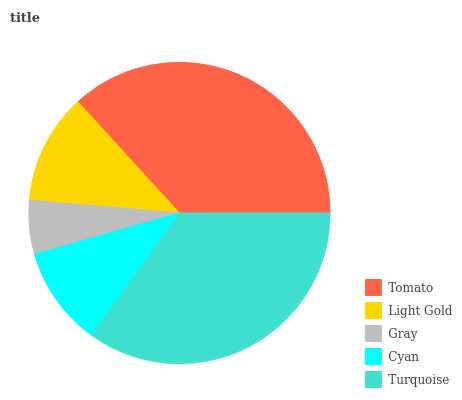Is Gray the minimum?
Answer yes or no. Yes. Is Tomato the maximum?
Answer yes or no. Yes. Is Light Gold the minimum?
Answer yes or no. No. Is Light Gold the maximum?
Answer yes or no. No. Is Tomato greater than Light Gold?
Answer yes or no. Yes. Is Light Gold less than Tomato?
Answer yes or no. Yes. Is Light Gold greater than Tomato?
Answer yes or no. No. Is Tomato less than Light Gold?
Answer yes or no. No. Is Light Gold the high median?
Answer yes or no. Yes. Is Light Gold the low median?
Answer yes or no. Yes. Is Gray the high median?
Answer yes or no. No. Is Tomato the low median?
Answer yes or no. No. 